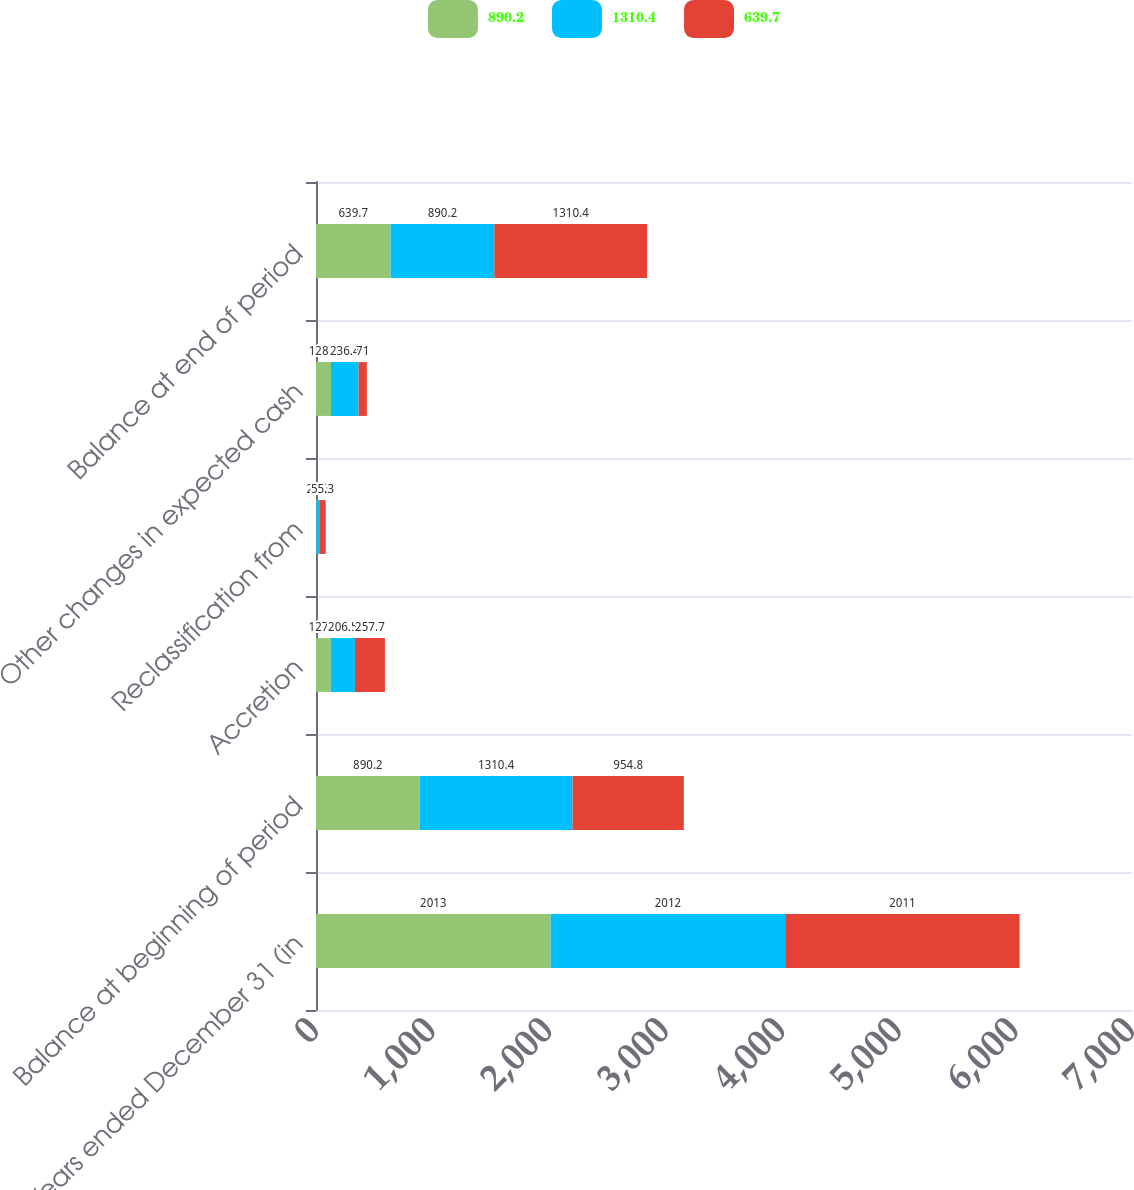Convert chart to OTSL. <chart><loc_0><loc_0><loc_500><loc_500><stacked_bar_chart><ecel><fcel>Years ended December 31 (in<fcel>Balance at beginning of period<fcel>Accretion<fcel>Reclassification from<fcel>Other changes in expected cash<fcel>Balance at end of period<nl><fcel>890.2<fcel>2013<fcel>890.2<fcel>127.1<fcel>5.3<fcel>128.7<fcel>639.7<nl><fcel>1310.4<fcel>2012<fcel>1310.4<fcel>206.5<fcel>22.7<fcel>236.4<fcel>890.2<nl><fcel>639.7<fcel>2011<fcel>954.8<fcel>257.7<fcel>55.3<fcel>71<fcel>1310.4<nl></chart> 